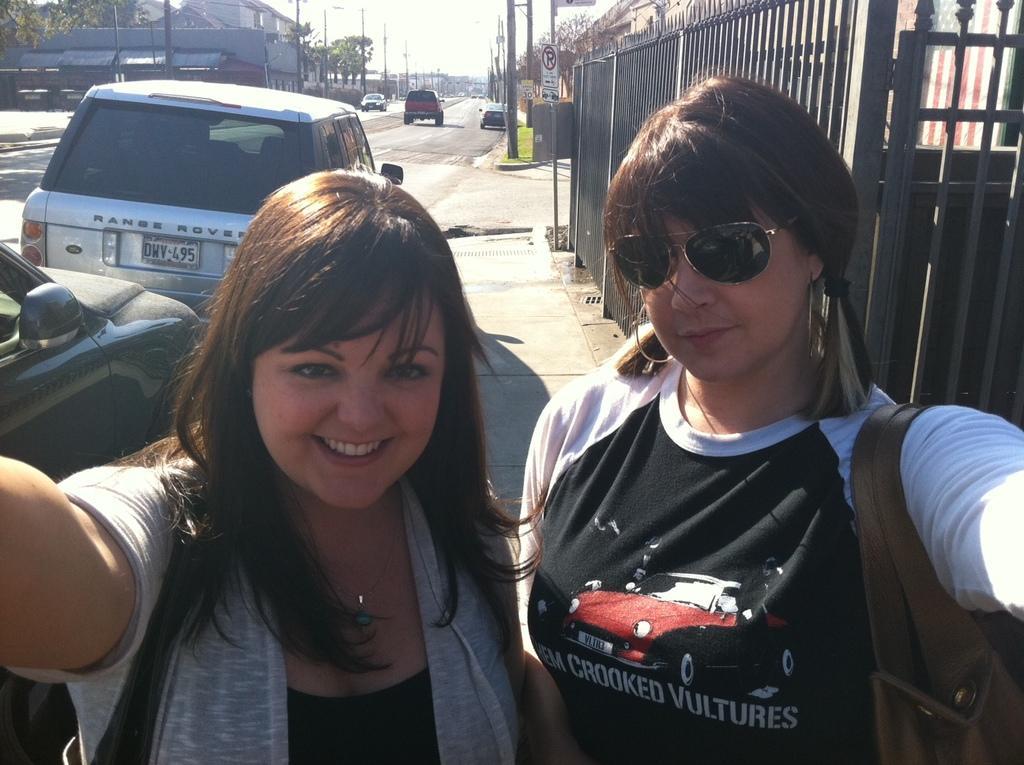Describe this image in one or two sentences. In this image I can see two women wearing black, grey and white colored dresses are standing and smiling. In the background I can see the black colored railing, the road, few vehicles on the road, few poles, few buildings, few trees and the sky in the background. 